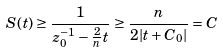<formula> <loc_0><loc_0><loc_500><loc_500>S ( t ) \geq \frac { 1 } { z ^ { - 1 } _ { 0 } - \frac { 2 } { n } t } \geq \frac { n } { 2 | t + C _ { 0 } | } = C</formula> 